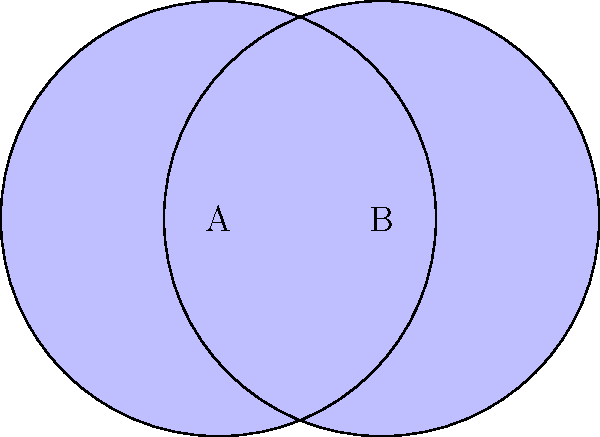In a poetic representation of interwoven verses, two crescents are formed by overlapping circles, each with a radius of 2 units. If the centers of the circles are 1.5 units apart, calculate the area of the region where the crescents intersect, reminiscent of the intertwining of languages in multilingual poetry. Express your answer in terms of π. Let's approach this step-by-step, drawing inspiration from the intricacy of Arabic poetry:

1) First, we need to find the area of the lens-shaped intersection. This can be done by subtracting the areas of two circular segments from the area of one circle.

2) The central angle of each segment can be found using the inverse cosine function:
   $$\theta = 2 \arccos(\frac{1.5}{4}) = 2 \arccos(0.375)$$

3) The area of a circular segment is given by:
   $$A_{segment} = r^2 \arccos(\frac{d}{2r}) - \frac{d}{2}\sqrt{4r^2 - d^2}$$
   where $r$ is the radius and $d$ is the distance between circle centers.

4) Substituting our values:
   $$A_{segment} = 4 \arccos(0.375) - \frac{1.5}{2}\sqrt{16 - 2.25}$$
   $$A_{segment} = 4 \arccos(0.375) - \frac{1.5}{2}\sqrt{13.75}$$

5) The area of the lens is twice the difference between the area of a circle sector and the area of a triangle:
   $$A_{lens} = 2(4 \arccos(0.375) - \frac{1.5}{2}\sqrt{13.75})$$

6) The area of each full circle is $4π$ square units.

7) The area of each crescent is the difference between the area of the circle and the area of the lens:
   $$A_{crescent} = 4π - (4 \arccos(0.375) - \frac{1.5}{2}\sqrt{13.75})$$

8) The intersection of the crescents is the lens-shaped region we calculated in step 5.

Therefore, the area of the intersection of the crescents is:
$$A_{intersection} = 2(4 \arccos(0.375) - \frac{1.5}{2}\sqrt{13.75})$$
Answer: $8 \arccos(0.375) - 1.5\sqrt{13.75}$ square units 